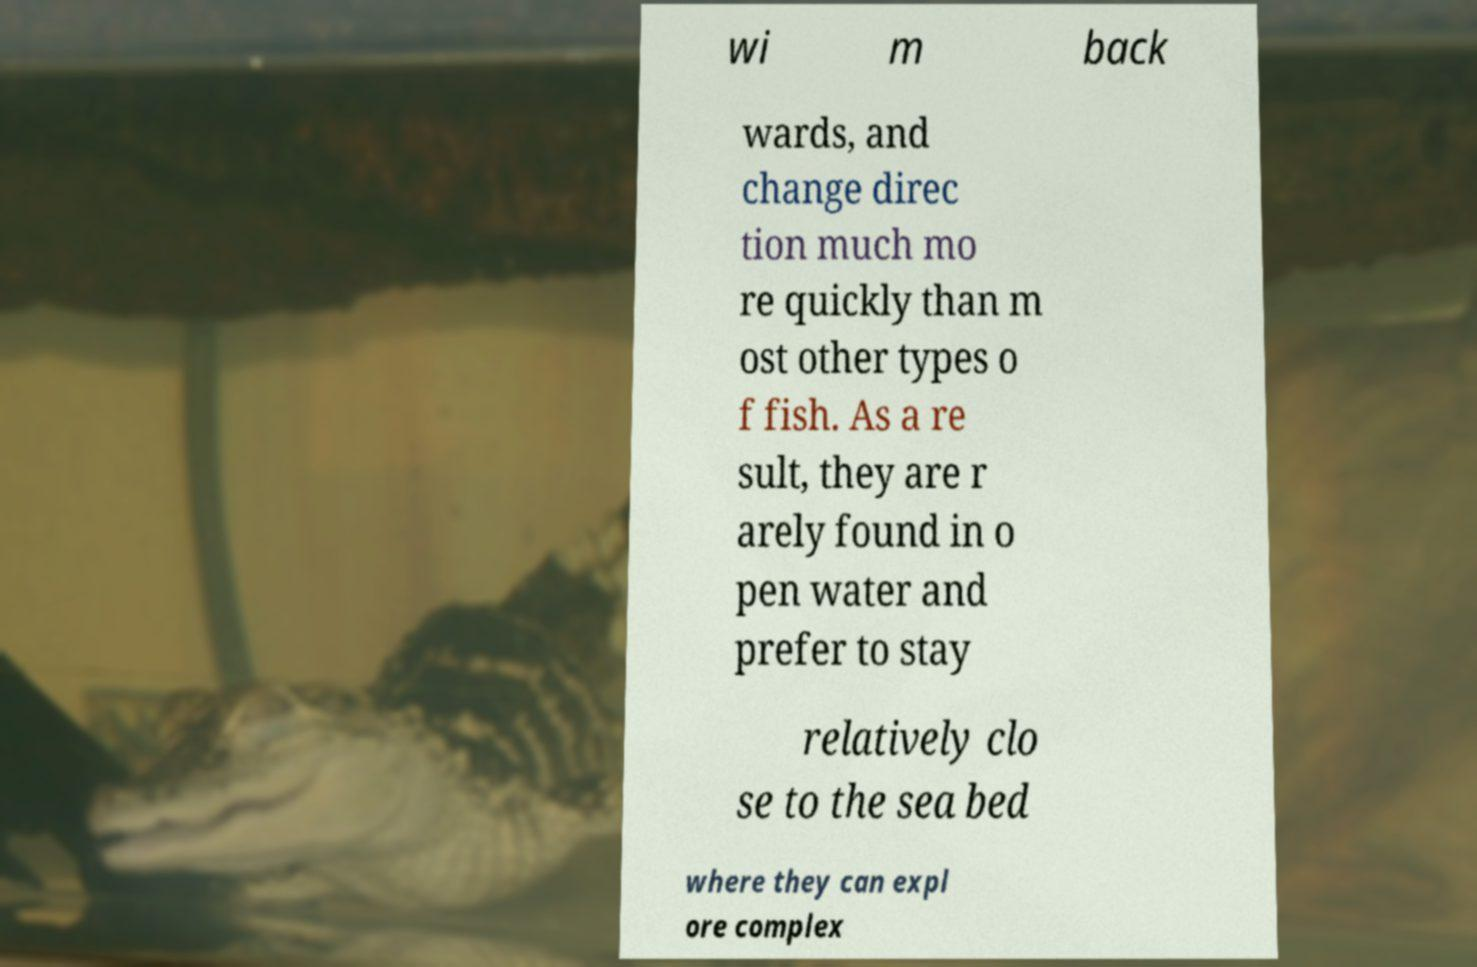Could you assist in decoding the text presented in this image and type it out clearly? wi m back wards, and change direc tion much mo re quickly than m ost other types o f fish. As a re sult, they are r arely found in o pen water and prefer to stay relatively clo se to the sea bed where they can expl ore complex 